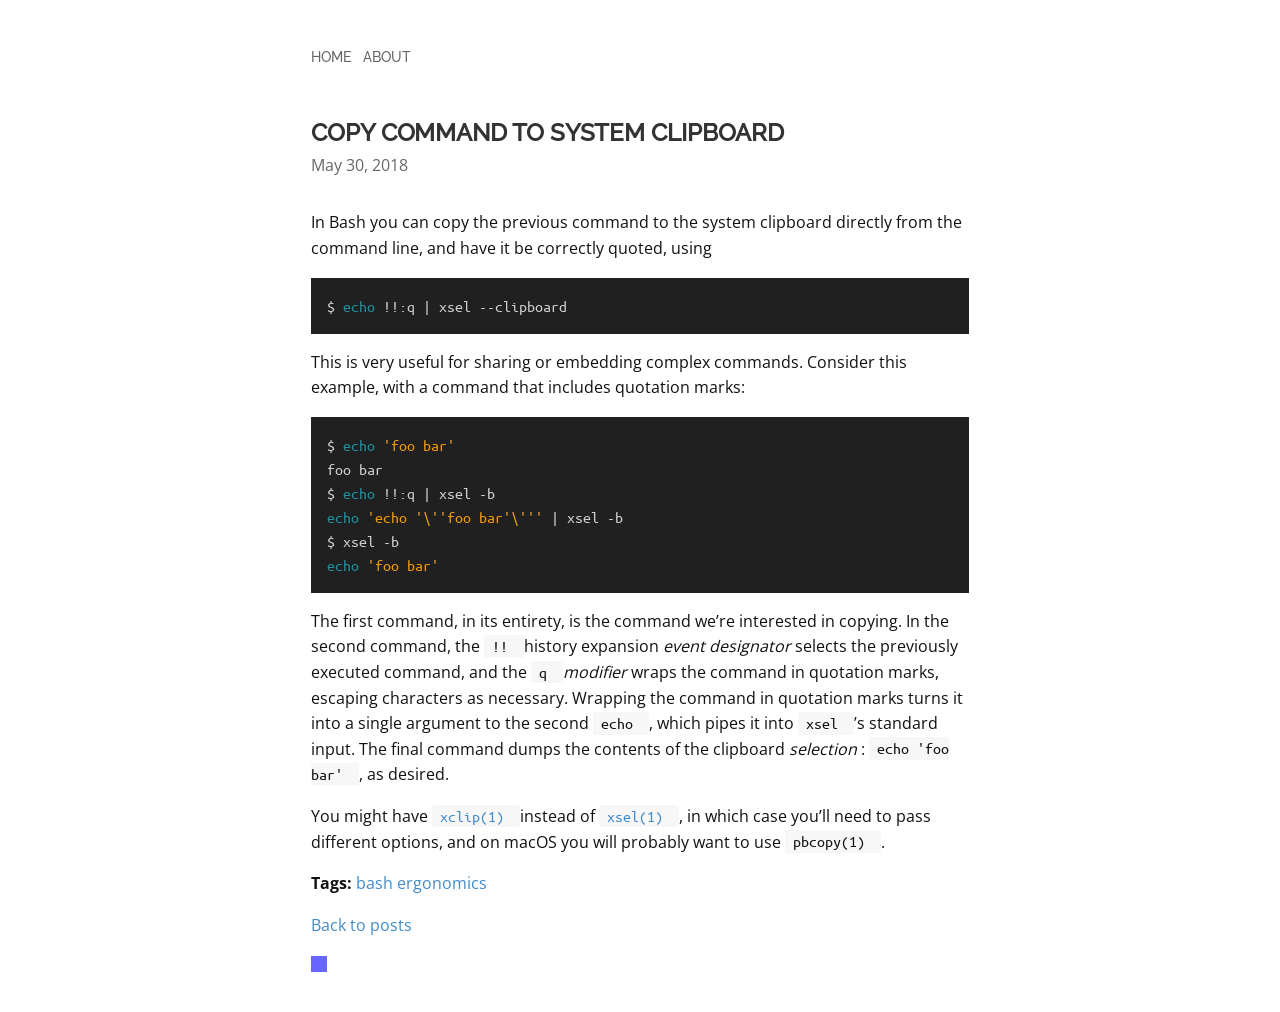What's the procedure for constructing this website from scratch with HTML? To recreate the website shown in the image, you'll need to use HTML for structuring and CSS for styling. Start with a basic HTML document structure including doctype declaration and head elements. Use <div> tags to create distinct sections like the 'Copy command to system clipboard', mirroring the layout in the image. Employ CSS to style fonts similar to the monospace type used in the command examples and set appropriate margins and padding to simulate the clean layout. Use classes to manage styles and maintain flexibility. Additionally, for the interactive command-line input as seen, consider using JavaScript to allow users to input their commands and have them display correctly. 